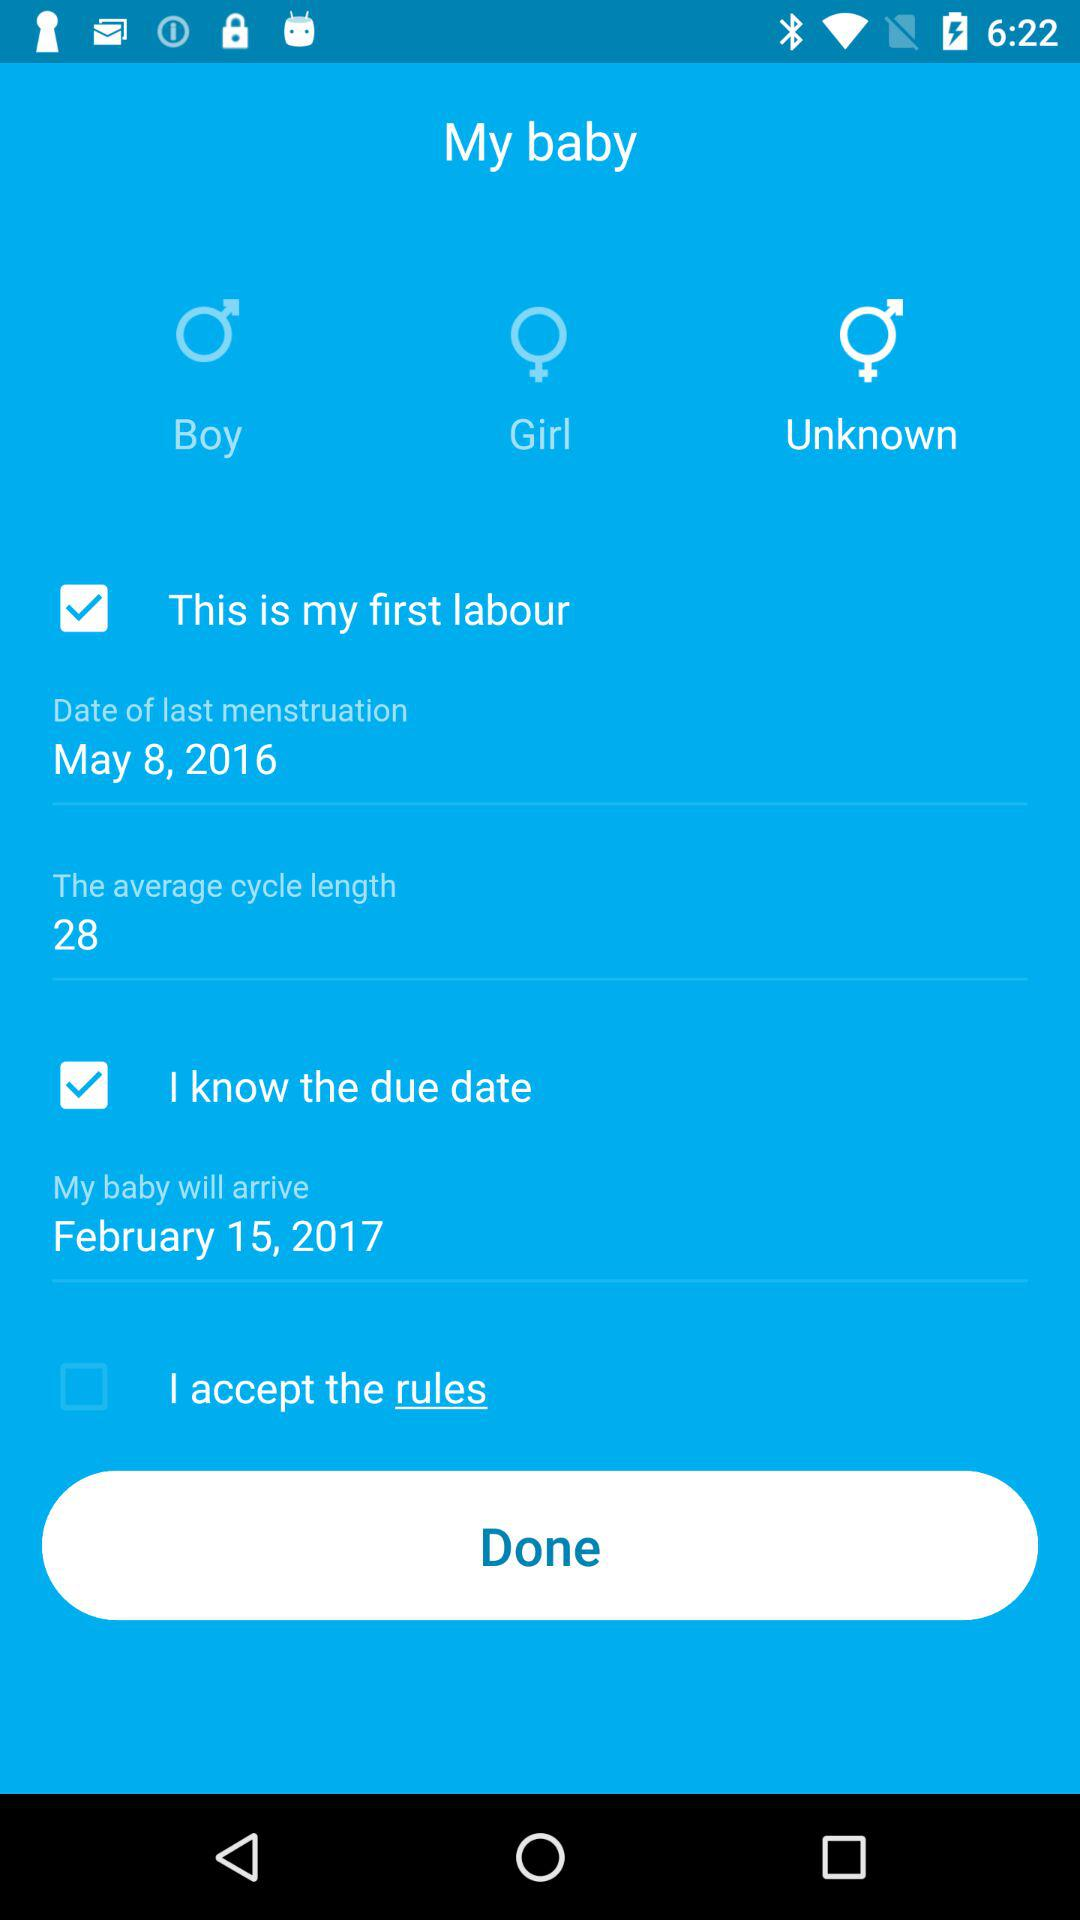What is the date of last menstruation? The date of last menstruation was 8th May, 2016. 